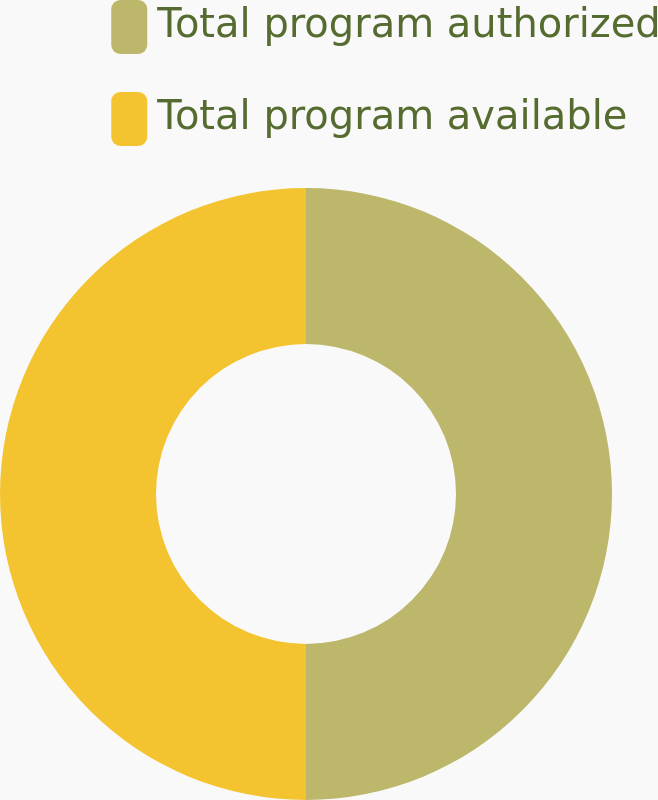<chart> <loc_0><loc_0><loc_500><loc_500><pie_chart><fcel>Total program authorized<fcel>Total program available<nl><fcel>50.0%<fcel>50.0%<nl></chart> 